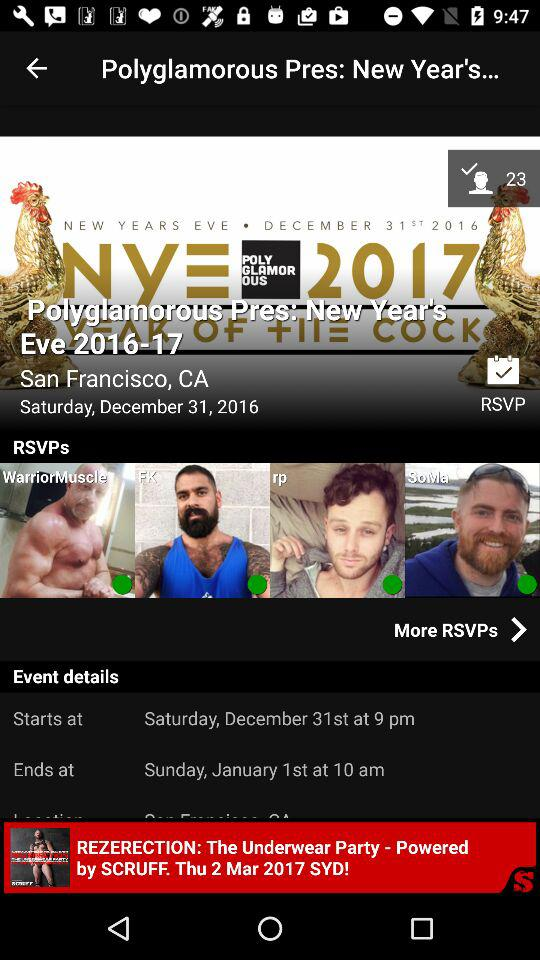What was the day on which the "Polyglamorous Pres: New Year's Eve" was held? The day was Saturday. 